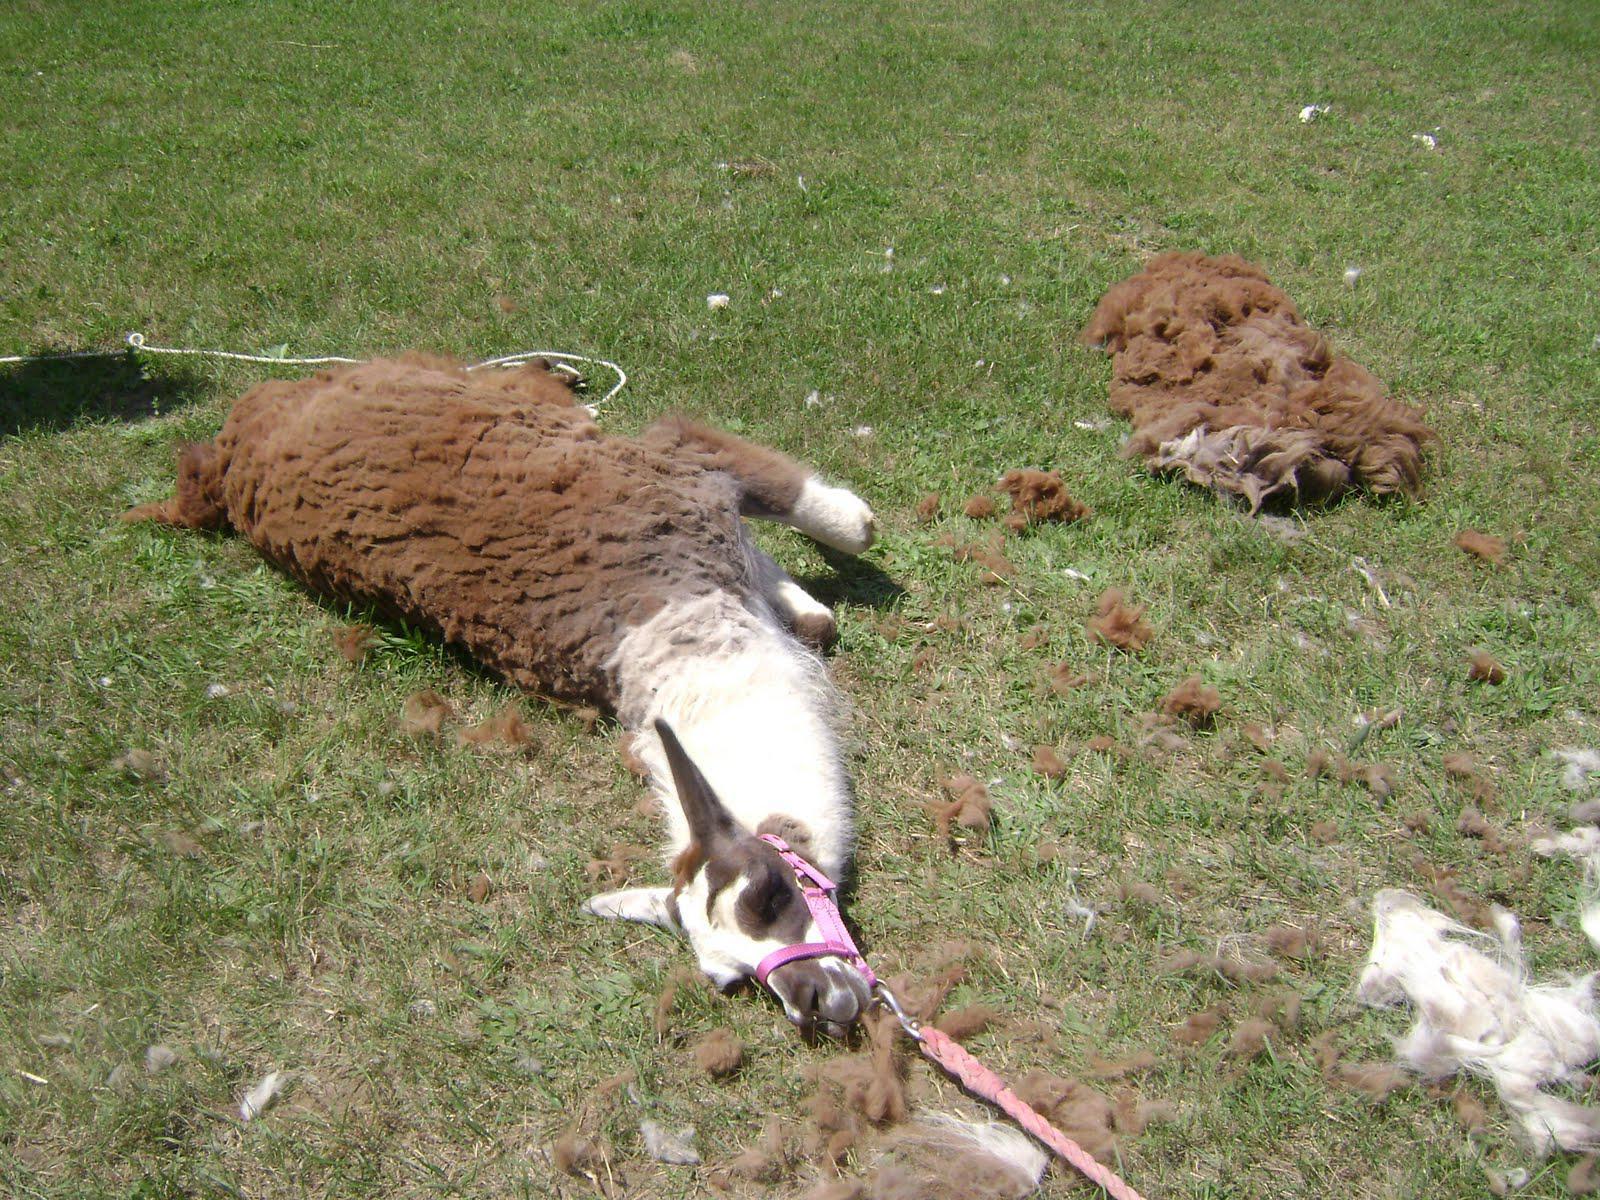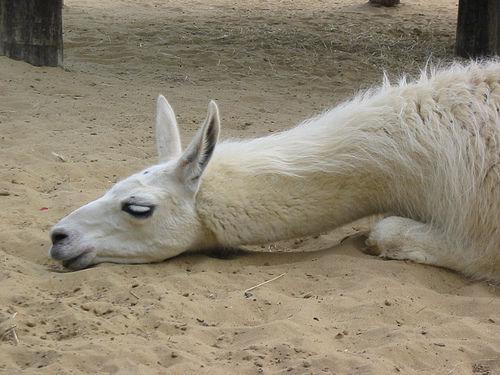The first image is the image on the left, the second image is the image on the right. Examine the images to the left and right. Is the description "Each image contains one llama lying on the ground, and the left image features a brown-and-white llma with a pink harness and a rope at its tail end lying on its side on the grass." accurate? Answer yes or no. Yes. The first image is the image on the left, the second image is the image on the right. Considering the images on both sides, is "In one of the images, the llama has a leash on his neck." valid? Answer yes or no. Yes. 